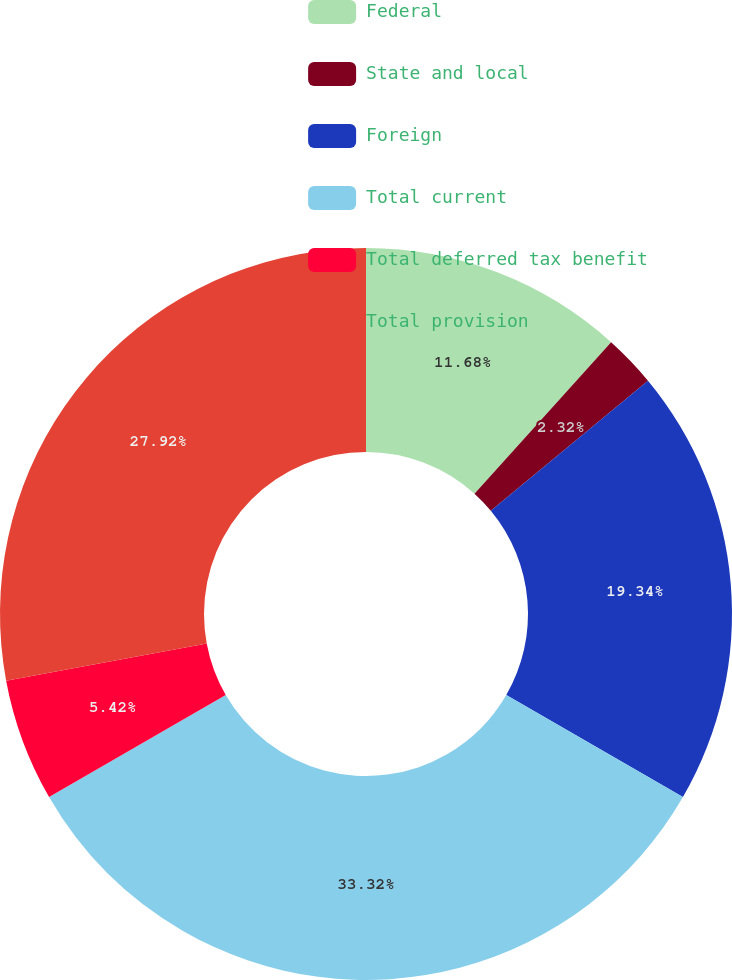Convert chart. <chart><loc_0><loc_0><loc_500><loc_500><pie_chart><fcel>Federal<fcel>State and local<fcel>Foreign<fcel>Total current<fcel>Total deferred tax benefit<fcel>Total provision<nl><fcel>11.68%<fcel>2.32%<fcel>19.34%<fcel>33.33%<fcel>5.42%<fcel>27.92%<nl></chart> 